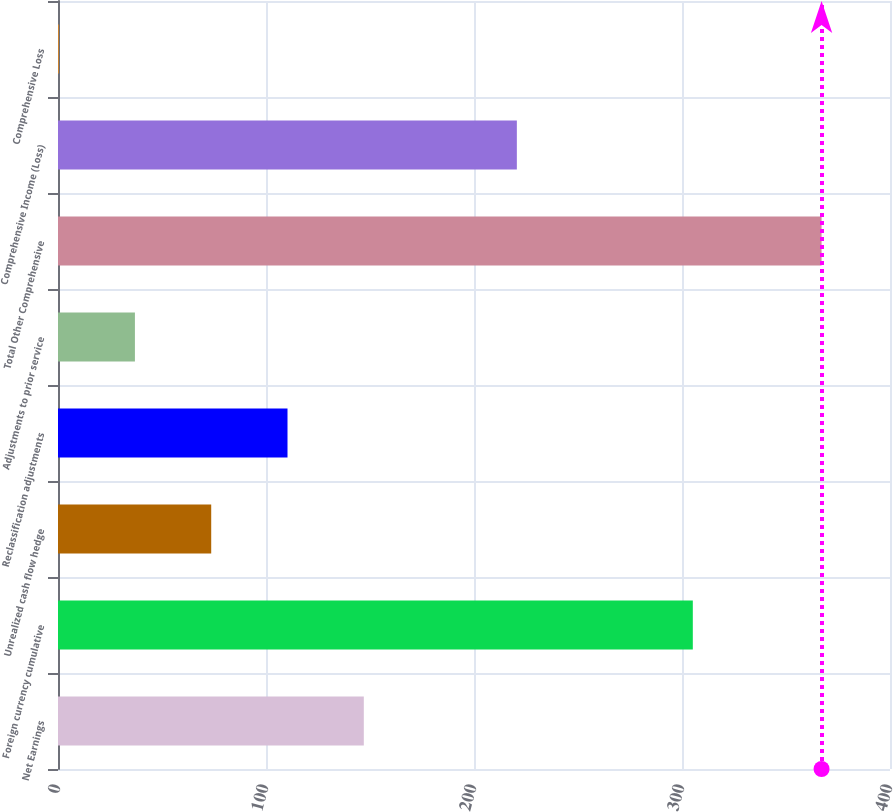Convert chart. <chart><loc_0><loc_0><loc_500><loc_500><bar_chart><fcel>Net Earnings<fcel>Foreign currency cumulative<fcel>Unrealized cash flow hedge<fcel>Reclassification adjustments<fcel>Adjustments to prior service<fcel>Total Other Comprehensive<fcel>Comprehensive Income (Loss)<fcel>Comprehensive Loss<nl><fcel>147.02<fcel>305.2<fcel>73.66<fcel>110.34<fcel>36.98<fcel>367.1<fcel>220.6<fcel>0.3<nl></chart> 